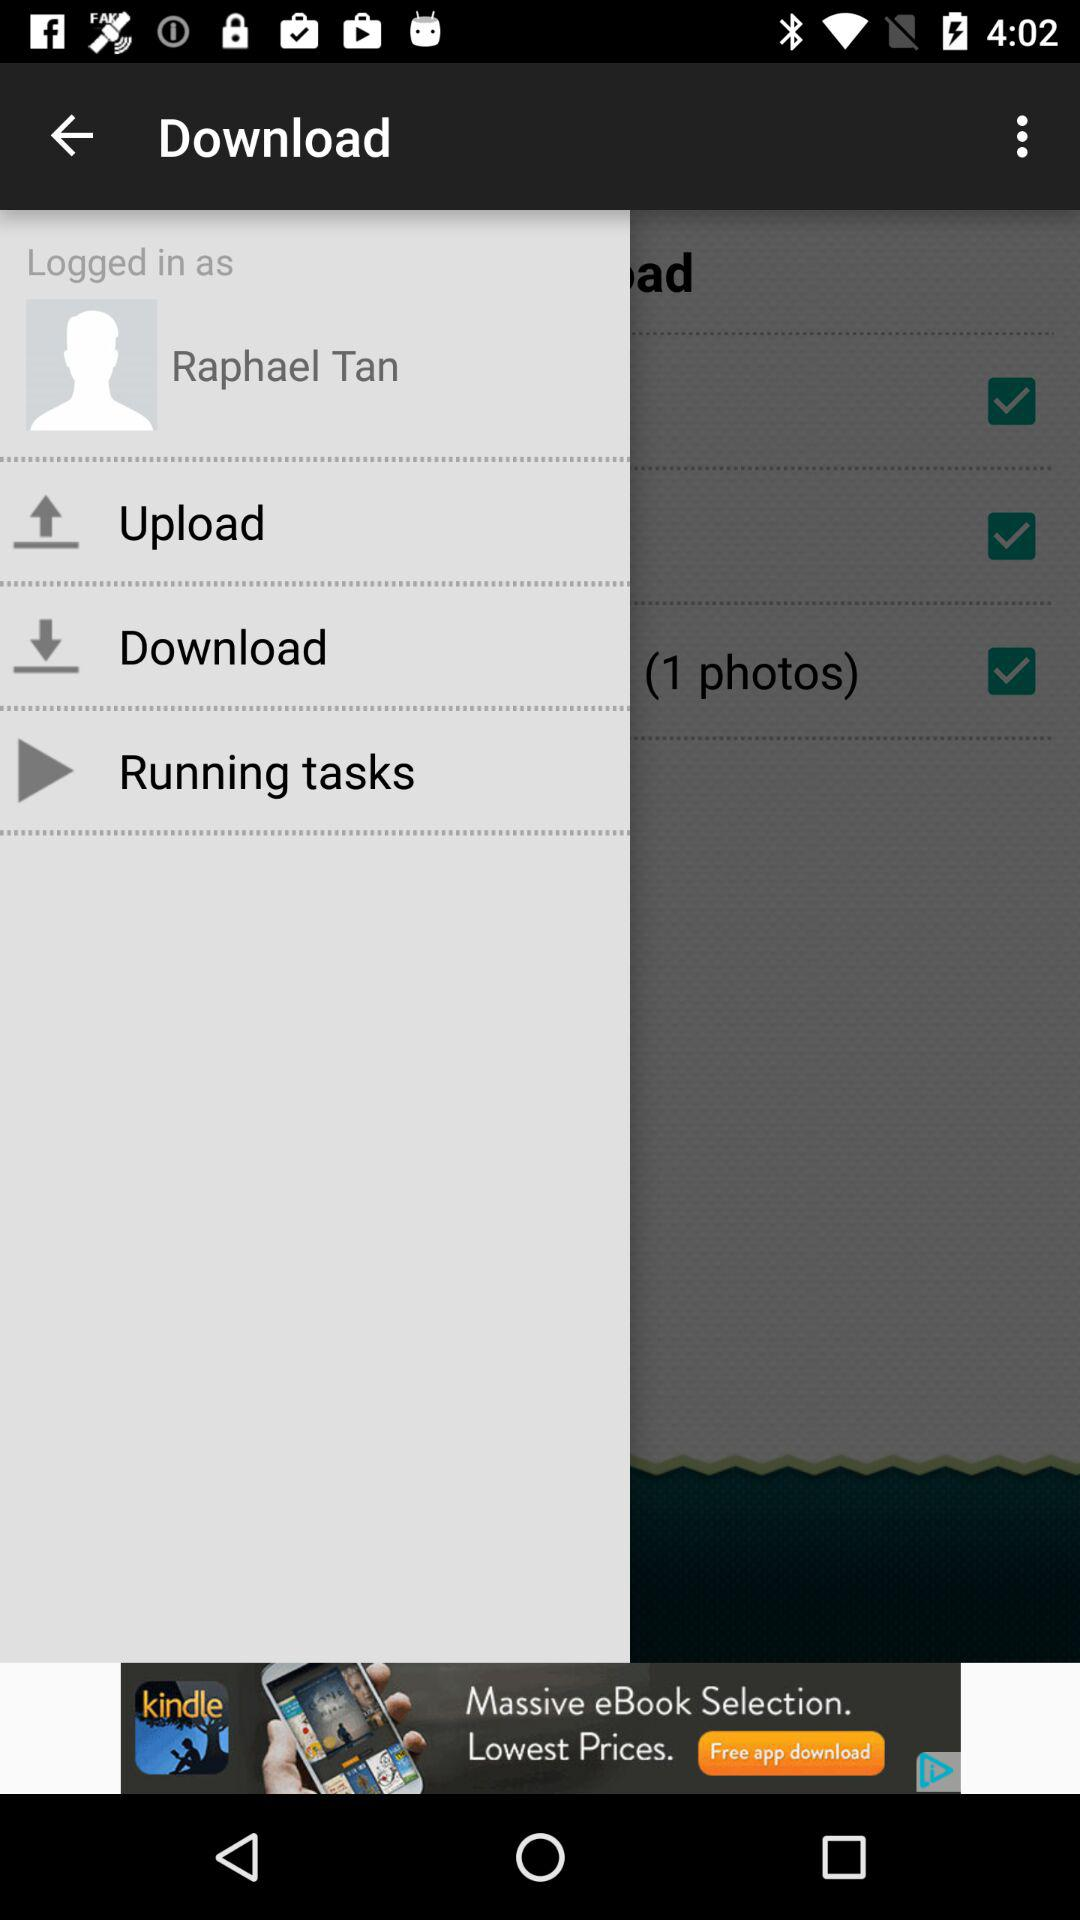What is the profile name? The profile name is Raphael Tan. 